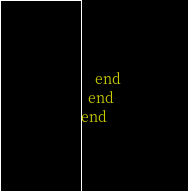<code> <loc_0><loc_0><loc_500><loc_500><_Ruby_>    end
  end
end
</code> 